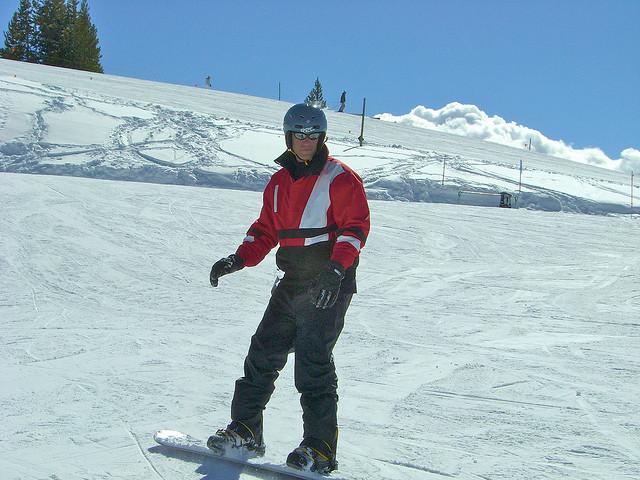What is the person doing?
Quick response, please. Snowboarding. How much snow is on the floor?
Write a very short answer. Lot. Is this snowshoeing?
Quick response, please. No. 